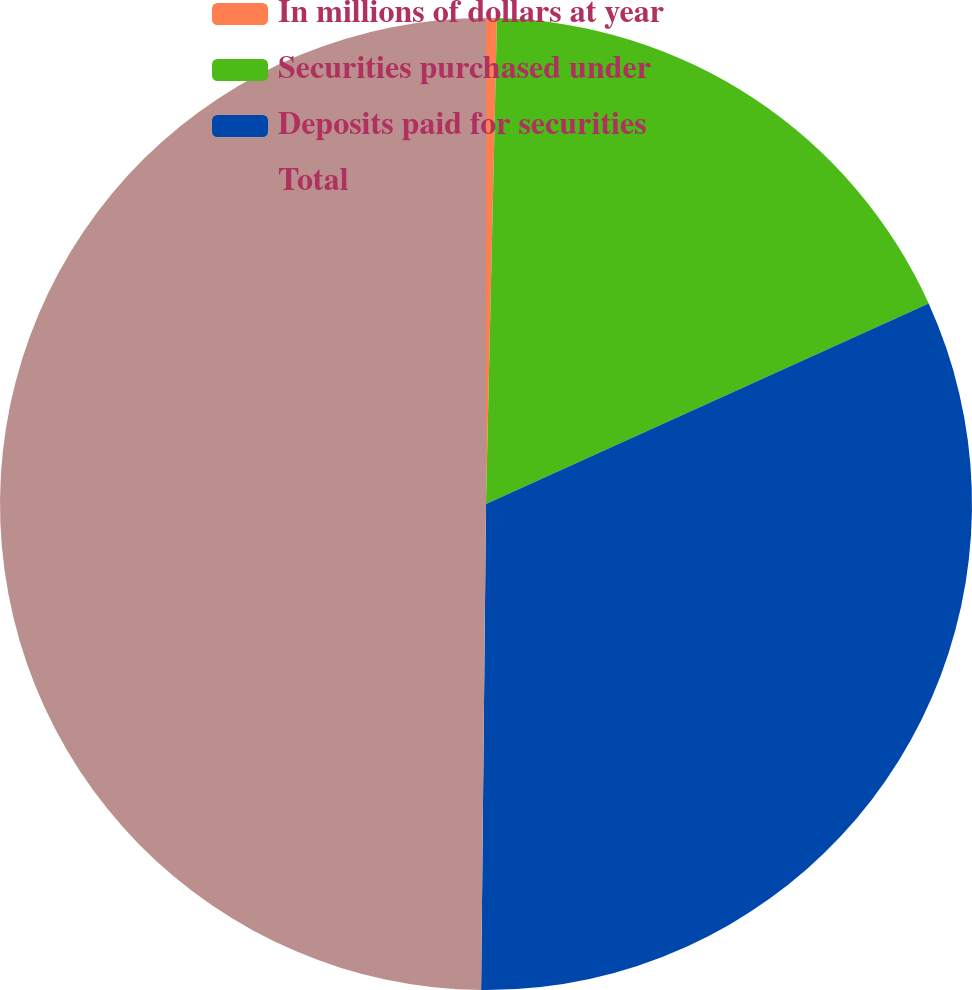Convert chart to OTSL. <chart><loc_0><loc_0><loc_500><loc_500><pie_chart><fcel>In millions of dollars at year<fcel>Securities purchased under<fcel>Deposits paid for securities<fcel>Total<nl><fcel>0.36%<fcel>17.87%<fcel>31.93%<fcel>49.84%<nl></chart> 